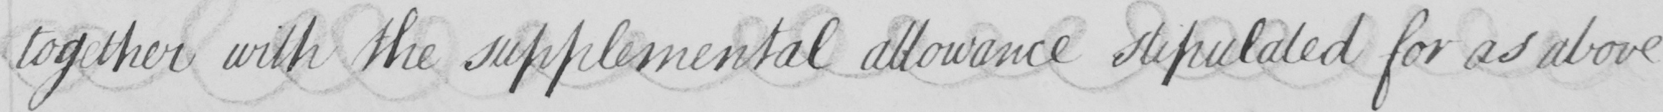Can you read and transcribe this handwriting? together with the supplemental allowance stipulated for as above 